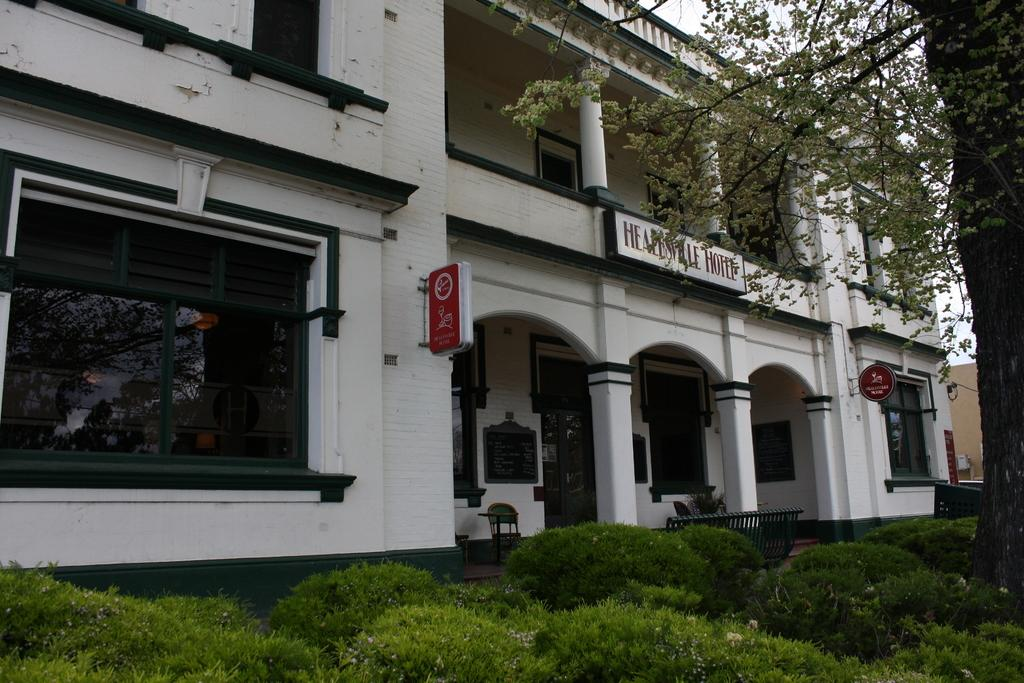What type of vegetation can be seen in the image? There are plants and trees in the image. Can you describe the background of the image? There is a building in the background of the image. What color is the blood on the elbow of the person holding the balloon in the image? There is no person, blood, or balloon present in the image. 